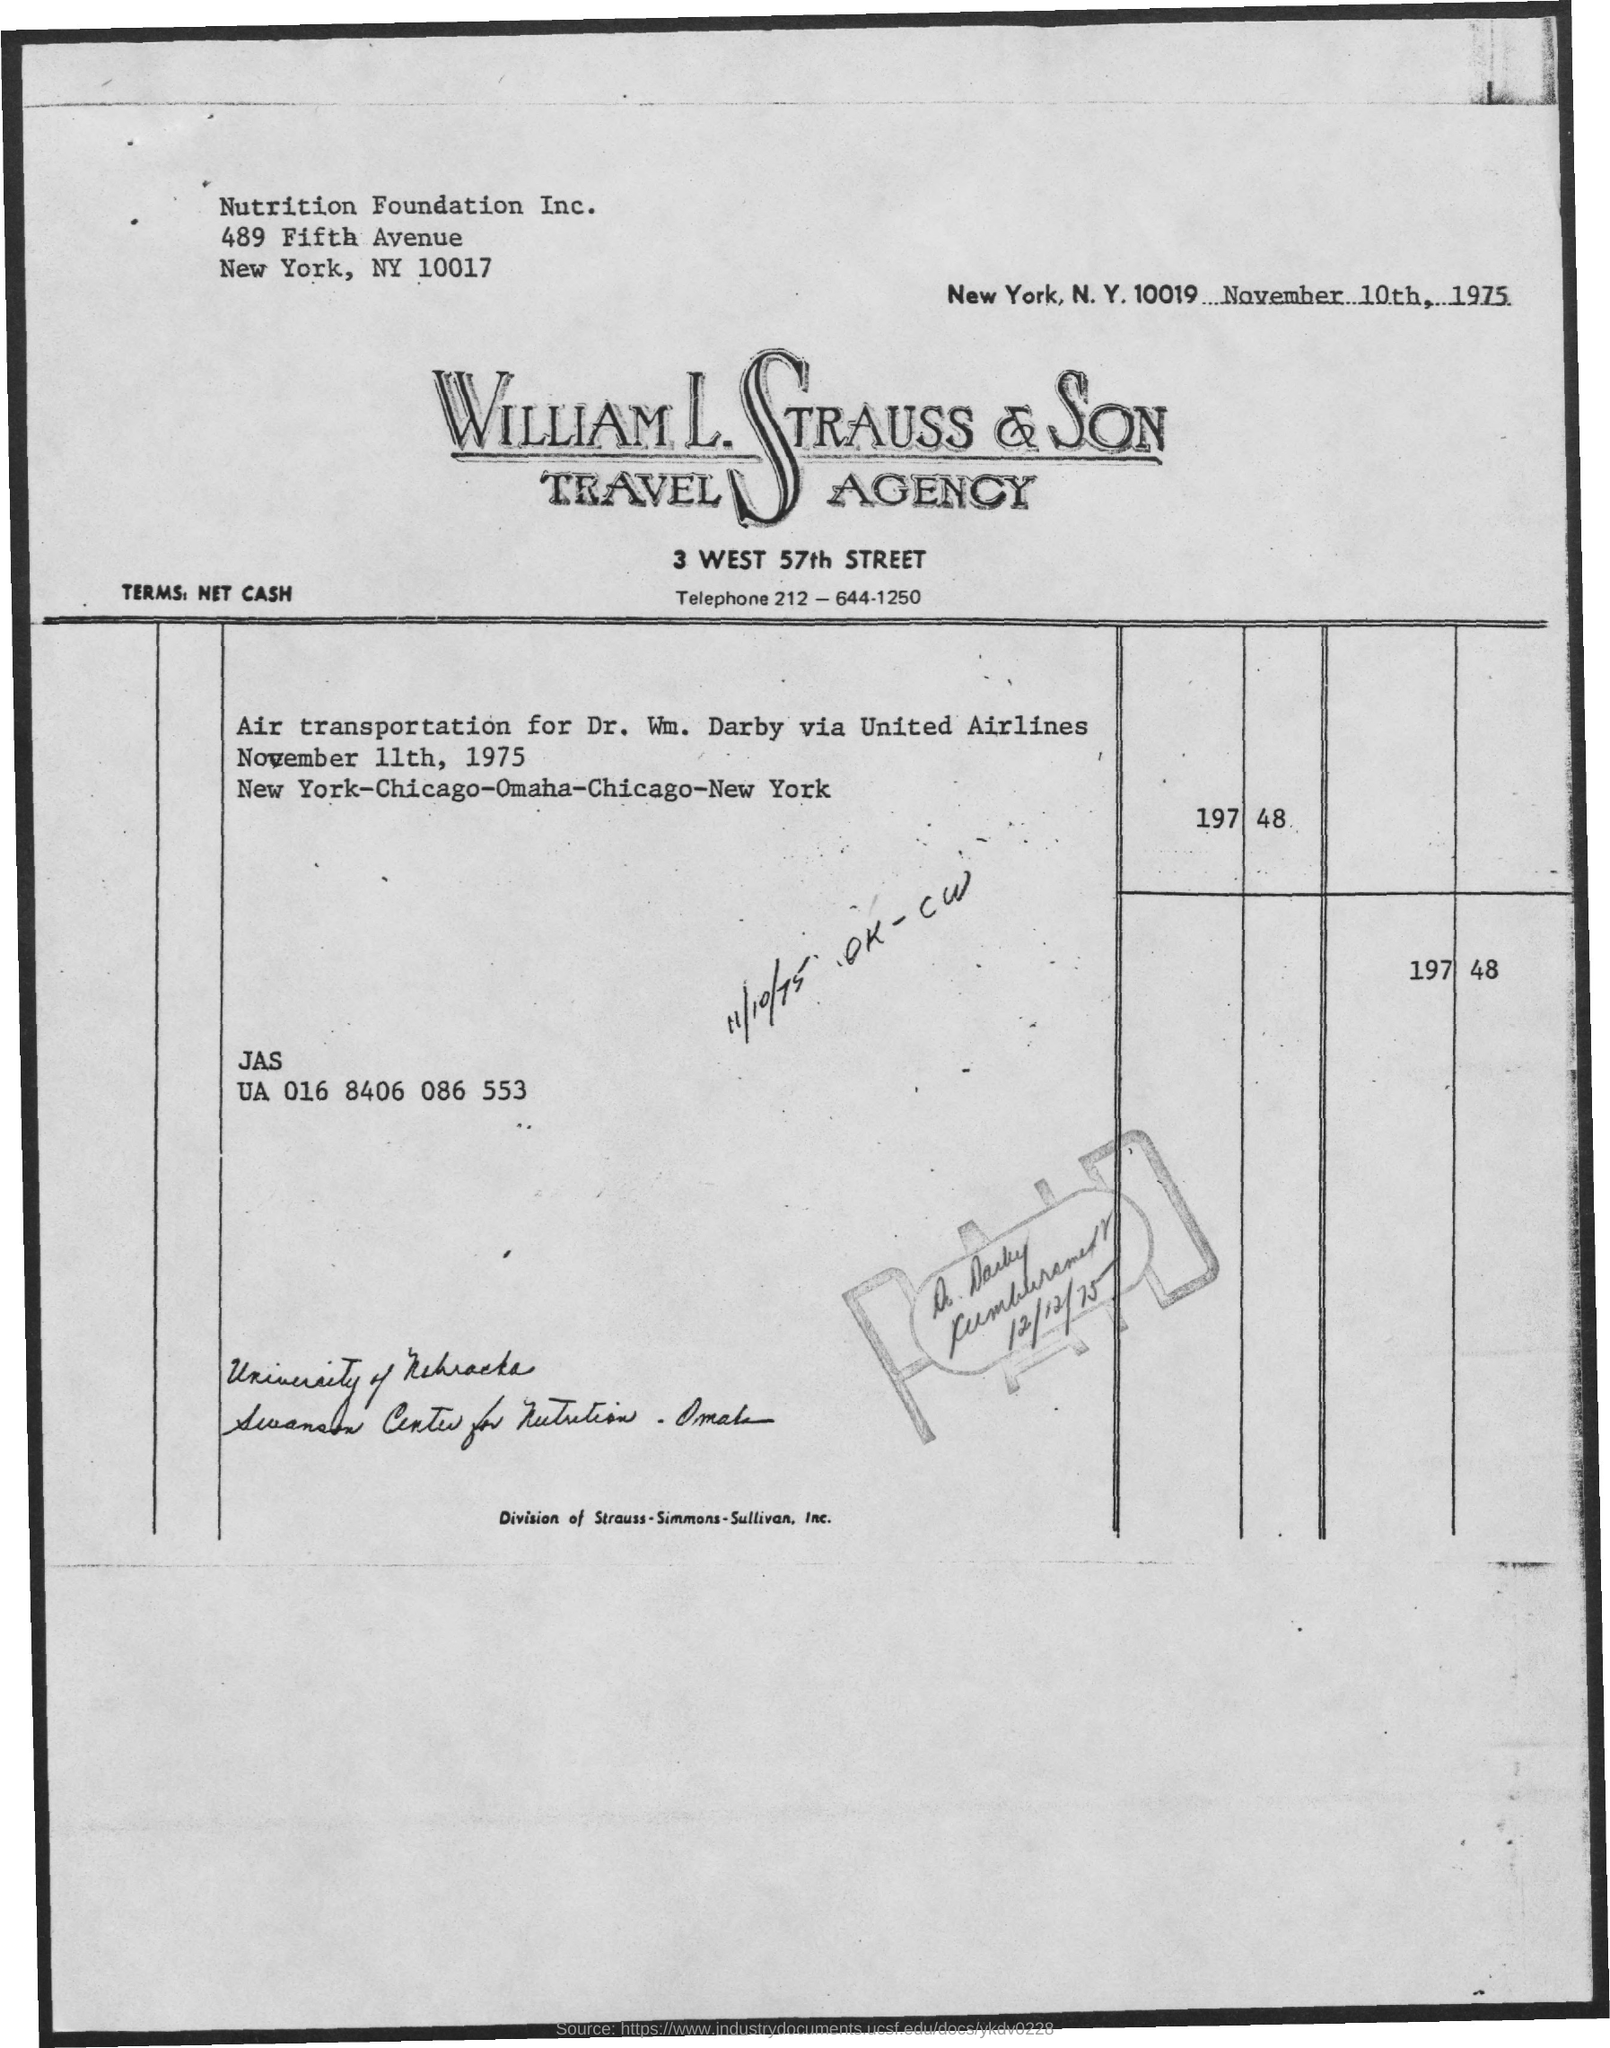What is the issued date of this invoice?
Provide a succinct answer. November 10th, 1975. To which company, the invoice is addressed?
Your answer should be compact. Nutrition Foundation Inc. 